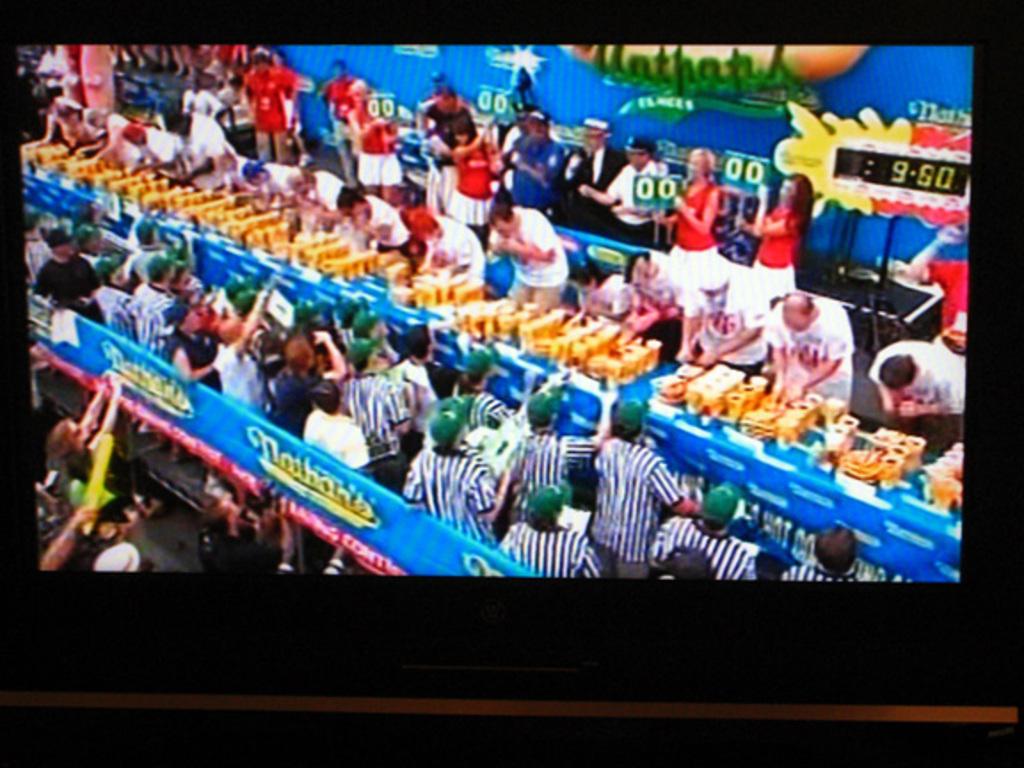What hotdogs are being sold today?
Make the answer very short. Nathans. What time is shown?
Offer a terse response. 9:50. 